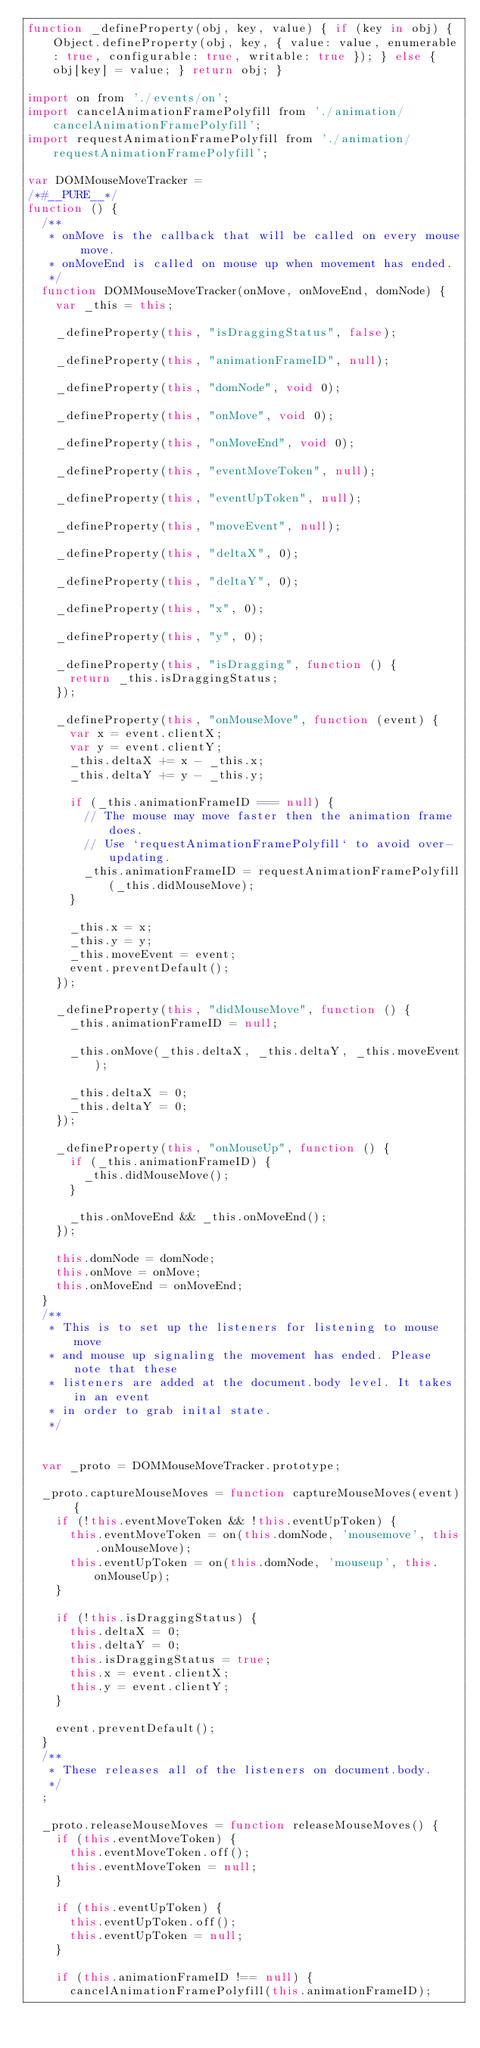Convert code to text. <code><loc_0><loc_0><loc_500><loc_500><_JavaScript_>function _defineProperty(obj, key, value) { if (key in obj) { Object.defineProperty(obj, key, { value: value, enumerable: true, configurable: true, writable: true }); } else { obj[key] = value; } return obj; }

import on from './events/on';
import cancelAnimationFramePolyfill from './animation/cancelAnimationFramePolyfill';
import requestAnimationFramePolyfill from './animation/requestAnimationFramePolyfill';

var DOMMouseMoveTracker =
/*#__PURE__*/
function () {
  /**
   * onMove is the callback that will be called on every mouse move.
   * onMoveEnd is called on mouse up when movement has ended.
   */
  function DOMMouseMoveTracker(onMove, onMoveEnd, domNode) {
    var _this = this;

    _defineProperty(this, "isDraggingStatus", false);

    _defineProperty(this, "animationFrameID", null);

    _defineProperty(this, "domNode", void 0);

    _defineProperty(this, "onMove", void 0);

    _defineProperty(this, "onMoveEnd", void 0);

    _defineProperty(this, "eventMoveToken", null);

    _defineProperty(this, "eventUpToken", null);

    _defineProperty(this, "moveEvent", null);

    _defineProperty(this, "deltaX", 0);

    _defineProperty(this, "deltaY", 0);

    _defineProperty(this, "x", 0);

    _defineProperty(this, "y", 0);

    _defineProperty(this, "isDragging", function () {
      return _this.isDraggingStatus;
    });

    _defineProperty(this, "onMouseMove", function (event) {
      var x = event.clientX;
      var y = event.clientY;
      _this.deltaX += x - _this.x;
      _this.deltaY += y - _this.y;

      if (_this.animationFrameID === null) {
        // The mouse may move faster then the animation frame does.
        // Use `requestAnimationFramePolyfill` to avoid over-updating.
        _this.animationFrameID = requestAnimationFramePolyfill(_this.didMouseMove);
      }

      _this.x = x;
      _this.y = y;
      _this.moveEvent = event;
      event.preventDefault();
    });

    _defineProperty(this, "didMouseMove", function () {
      _this.animationFrameID = null;

      _this.onMove(_this.deltaX, _this.deltaY, _this.moveEvent);

      _this.deltaX = 0;
      _this.deltaY = 0;
    });

    _defineProperty(this, "onMouseUp", function () {
      if (_this.animationFrameID) {
        _this.didMouseMove();
      }

      _this.onMoveEnd && _this.onMoveEnd();
    });

    this.domNode = domNode;
    this.onMove = onMove;
    this.onMoveEnd = onMoveEnd;
  }
  /**
   * This is to set up the listeners for listening to mouse move
   * and mouse up signaling the movement has ended. Please note that these
   * listeners are added at the document.body level. It takes in an event
   * in order to grab inital state.
   */


  var _proto = DOMMouseMoveTracker.prototype;

  _proto.captureMouseMoves = function captureMouseMoves(event) {
    if (!this.eventMoveToken && !this.eventUpToken) {
      this.eventMoveToken = on(this.domNode, 'mousemove', this.onMouseMove);
      this.eventUpToken = on(this.domNode, 'mouseup', this.onMouseUp);
    }

    if (!this.isDraggingStatus) {
      this.deltaX = 0;
      this.deltaY = 0;
      this.isDraggingStatus = true;
      this.x = event.clientX;
      this.y = event.clientY;
    }

    event.preventDefault();
  }
  /**
   * These releases all of the listeners on document.body.
   */
  ;

  _proto.releaseMouseMoves = function releaseMouseMoves() {
    if (this.eventMoveToken) {
      this.eventMoveToken.off();
      this.eventMoveToken = null;
    }

    if (this.eventUpToken) {
      this.eventUpToken.off();
      this.eventUpToken = null;
    }

    if (this.animationFrameID !== null) {
      cancelAnimationFramePolyfill(this.animationFrameID);</code> 